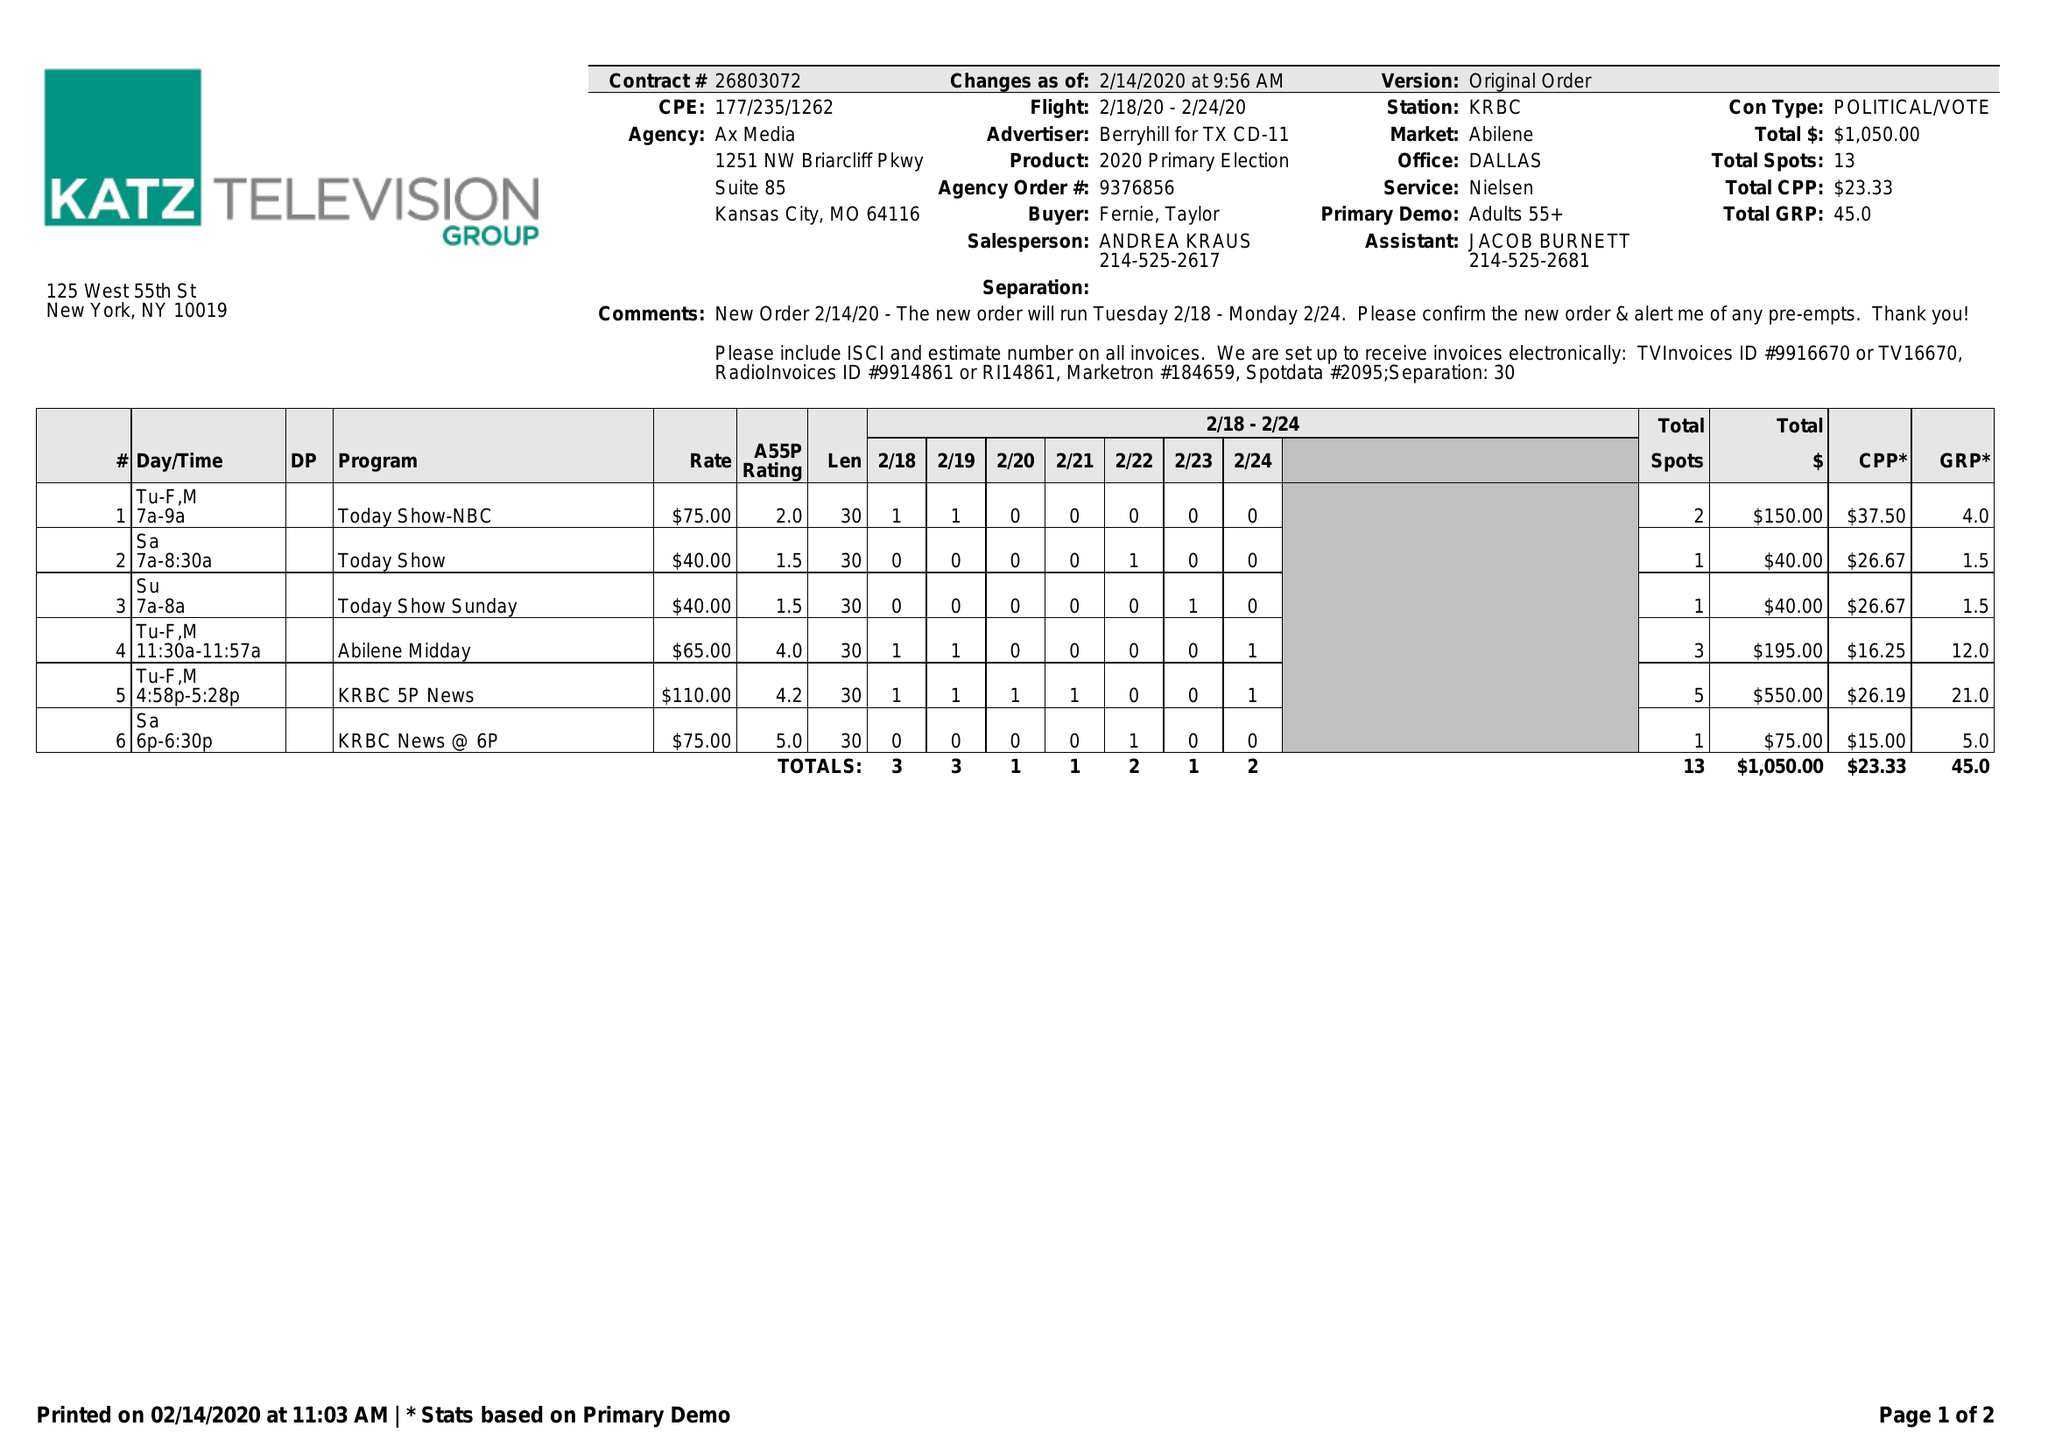What is the value for the flight_to?
Answer the question using a single word or phrase. 02/24/20 